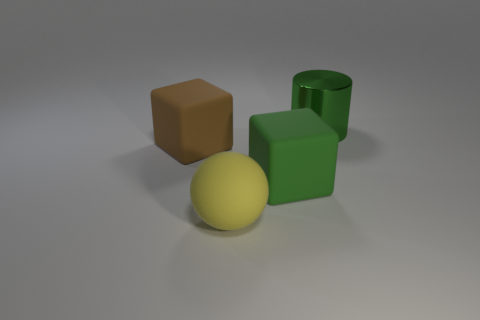Subtract all cylinders. How many objects are left? 3 Add 3 big green things. How many objects exist? 7 Subtract all big rubber balls. Subtract all large brown cylinders. How many objects are left? 3 Add 4 yellow matte balls. How many yellow matte balls are left? 5 Add 1 cubes. How many cubes exist? 3 Subtract 1 green cubes. How many objects are left? 3 